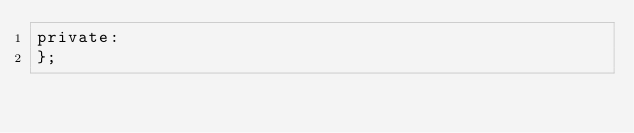Convert code to text. <code><loc_0><loc_0><loc_500><loc_500><_C_>private:
};</code> 